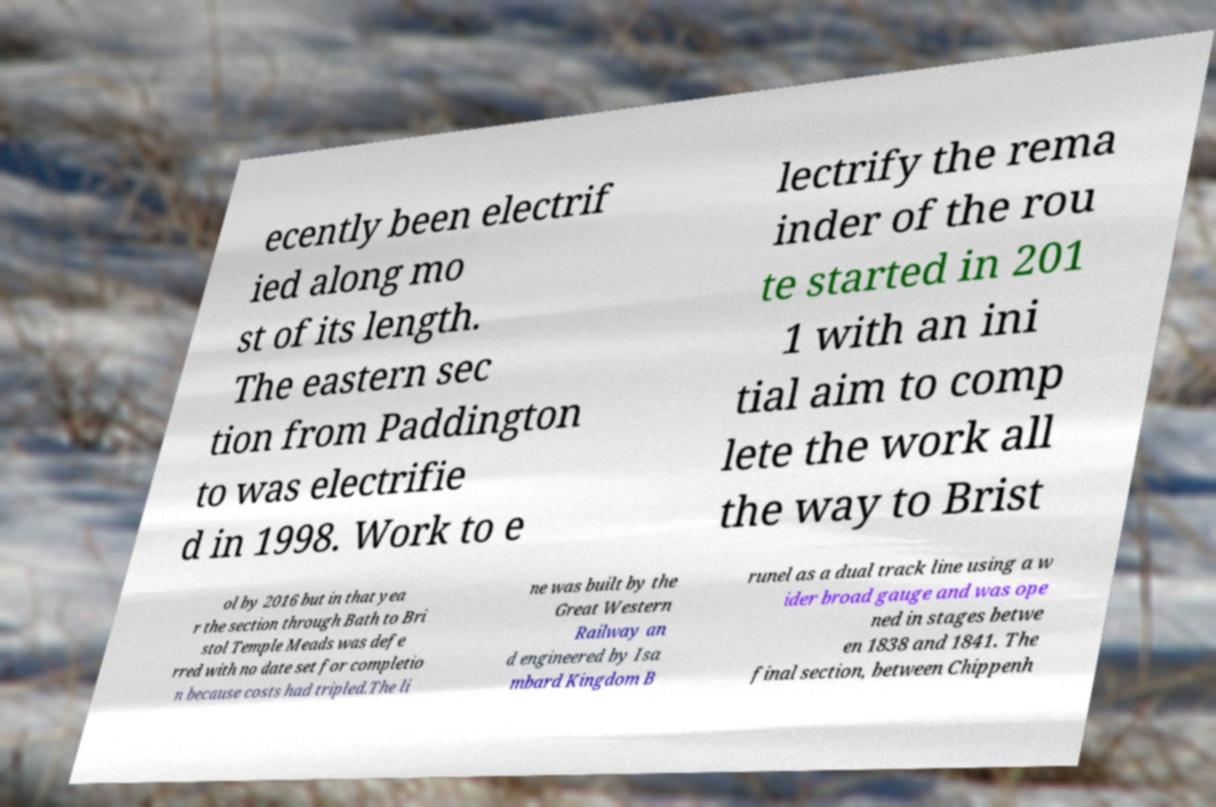There's text embedded in this image that I need extracted. Can you transcribe it verbatim? ecently been electrif ied along mo st of its length. The eastern sec tion from Paddington to was electrifie d in 1998. Work to e lectrify the rema inder of the rou te started in 201 1 with an ini tial aim to comp lete the work all the way to Brist ol by 2016 but in that yea r the section through Bath to Bri stol Temple Meads was defe rred with no date set for completio n because costs had tripled.The li ne was built by the Great Western Railway an d engineered by Isa mbard Kingdom B runel as a dual track line using a w ider broad gauge and was ope ned in stages betwe en 1838 and 1841. The final section, between Chippenh 